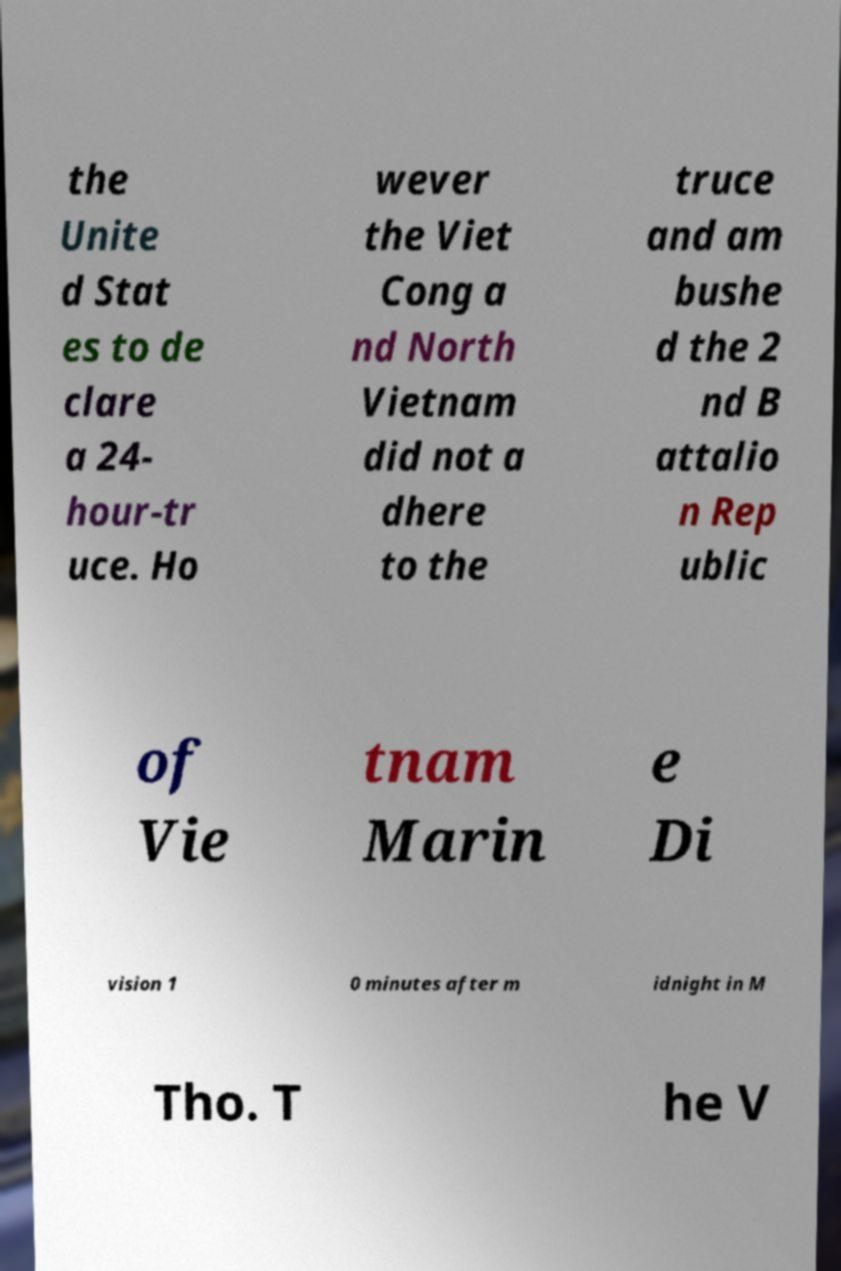I need the written content from this picture converted into text. Can you do that? the Unite d Stat es to de clare a 24- hour-tr uce. Ho wever the Viet Cong a nd North Vietnam did not a dhere to the truce and am bushe d the 2 nd B attalio n Rep ublic of Vie tnam Marin e Di vision 1 0 minutes after m idnight in M Tho. T he V 